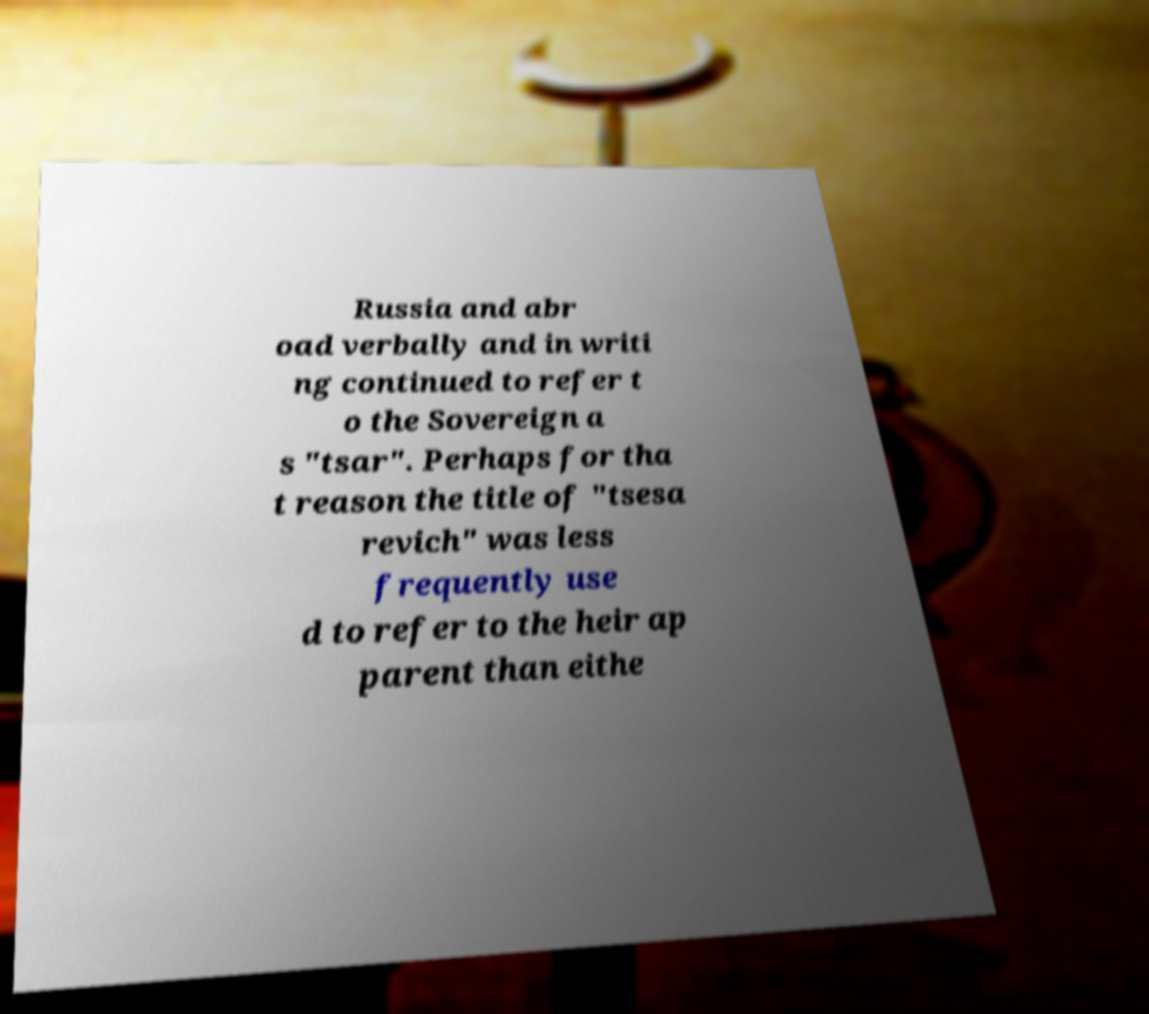Please identify and transcribe the text found in this image. Russia and abr oad verbally and in writi ng continued to refer t o the Sovereign a s "tsar". Perhaps for tha t reason the title of "tsesa revich" was less frequently use d to refer to the heir ap parent than eithe 